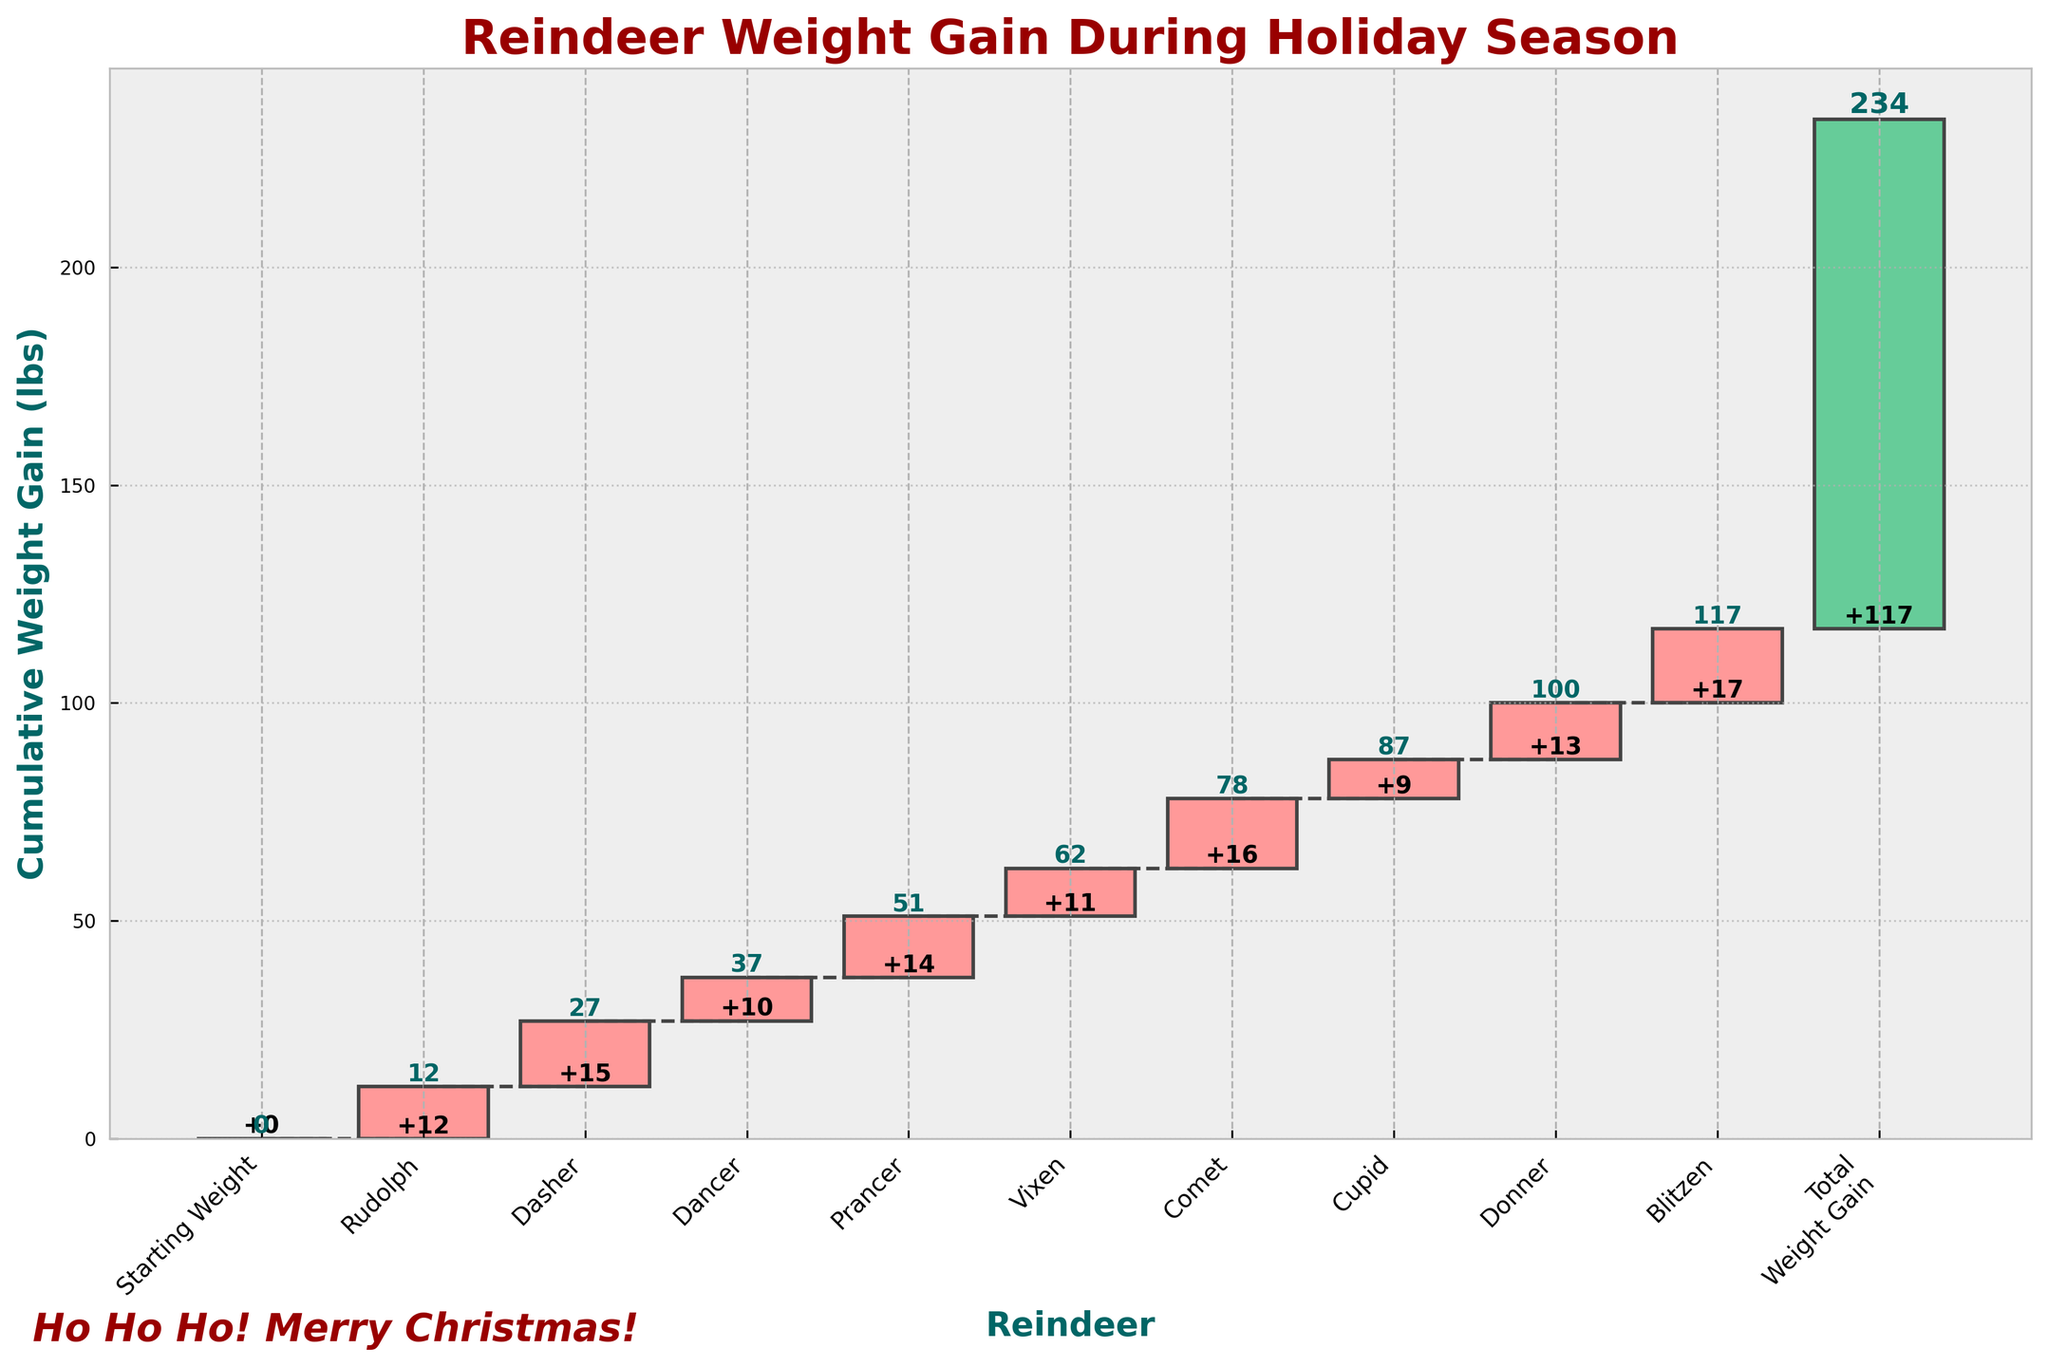What is the title of the chart? The title is given at the top of the chart and is in bold with a font size of 20.
Answer: Reindeer Weight Gain During Holiday Season What is the cumulative weight gain for Dasher? The cumulative weight gain for each reindeer shows the total weight gained up to and including that reindeer. For Dasher, it is the cumulative value just above and to the right of Dasher's bar.
Answer: 27 lbs How much weight did Blitzen gain? The value for each reindeer's weight change is shown inside or above the respective bars. For Blitzen, this value is marked clearly on the bar itself.
Answer: 17 lbs Which reindeer had the highest individual weight gain? By looking at each bar and comparing the individual weight changes labeled on them, we can identify the highest value.
Answer: Blitzen What is the total weight gain for all the reindeer combined? The total weight gain is displayed on the final bar labeled "Total Weight Gain" and it's the sum of the individual gains, indicated by the cumulative total text next to this bar.
Answer: 117 lbs What is the cumulative weight gain after Comet? The cumulative weight gain builds up across the chart and for Comet, it will be the cumulative value just above Comet's bar.
Answer: 87 lbs How does the weight gain of Prancer compare to Vixen? To compare the weight gains, look at the values marked on the bars for Prancer and Vixen.
Answer: Prancer gained 3 lbs more than Vixen What is the cumulative weight gain at the end of the plot? The cumulative gain at the end is shown next to the final bar labeled "Total Weight Gain".
Answer: 117 lbs If Comet gained 16 lbs, what was the cumulative weight gain just before Comet? The cumulative weight gain just before Comet would be the cumulative value excluding Comet's gain, which can be derived from the cumulative value next to the previous bar (Vixen).
Answer: 71 lbs From which reindeer does the cumulative weight start to exceed 50 lbs? The cumulative weight starts to exceed 50 lbs from the bar which has a cumulative value just above 50 lbs.
Answer: Dancer 